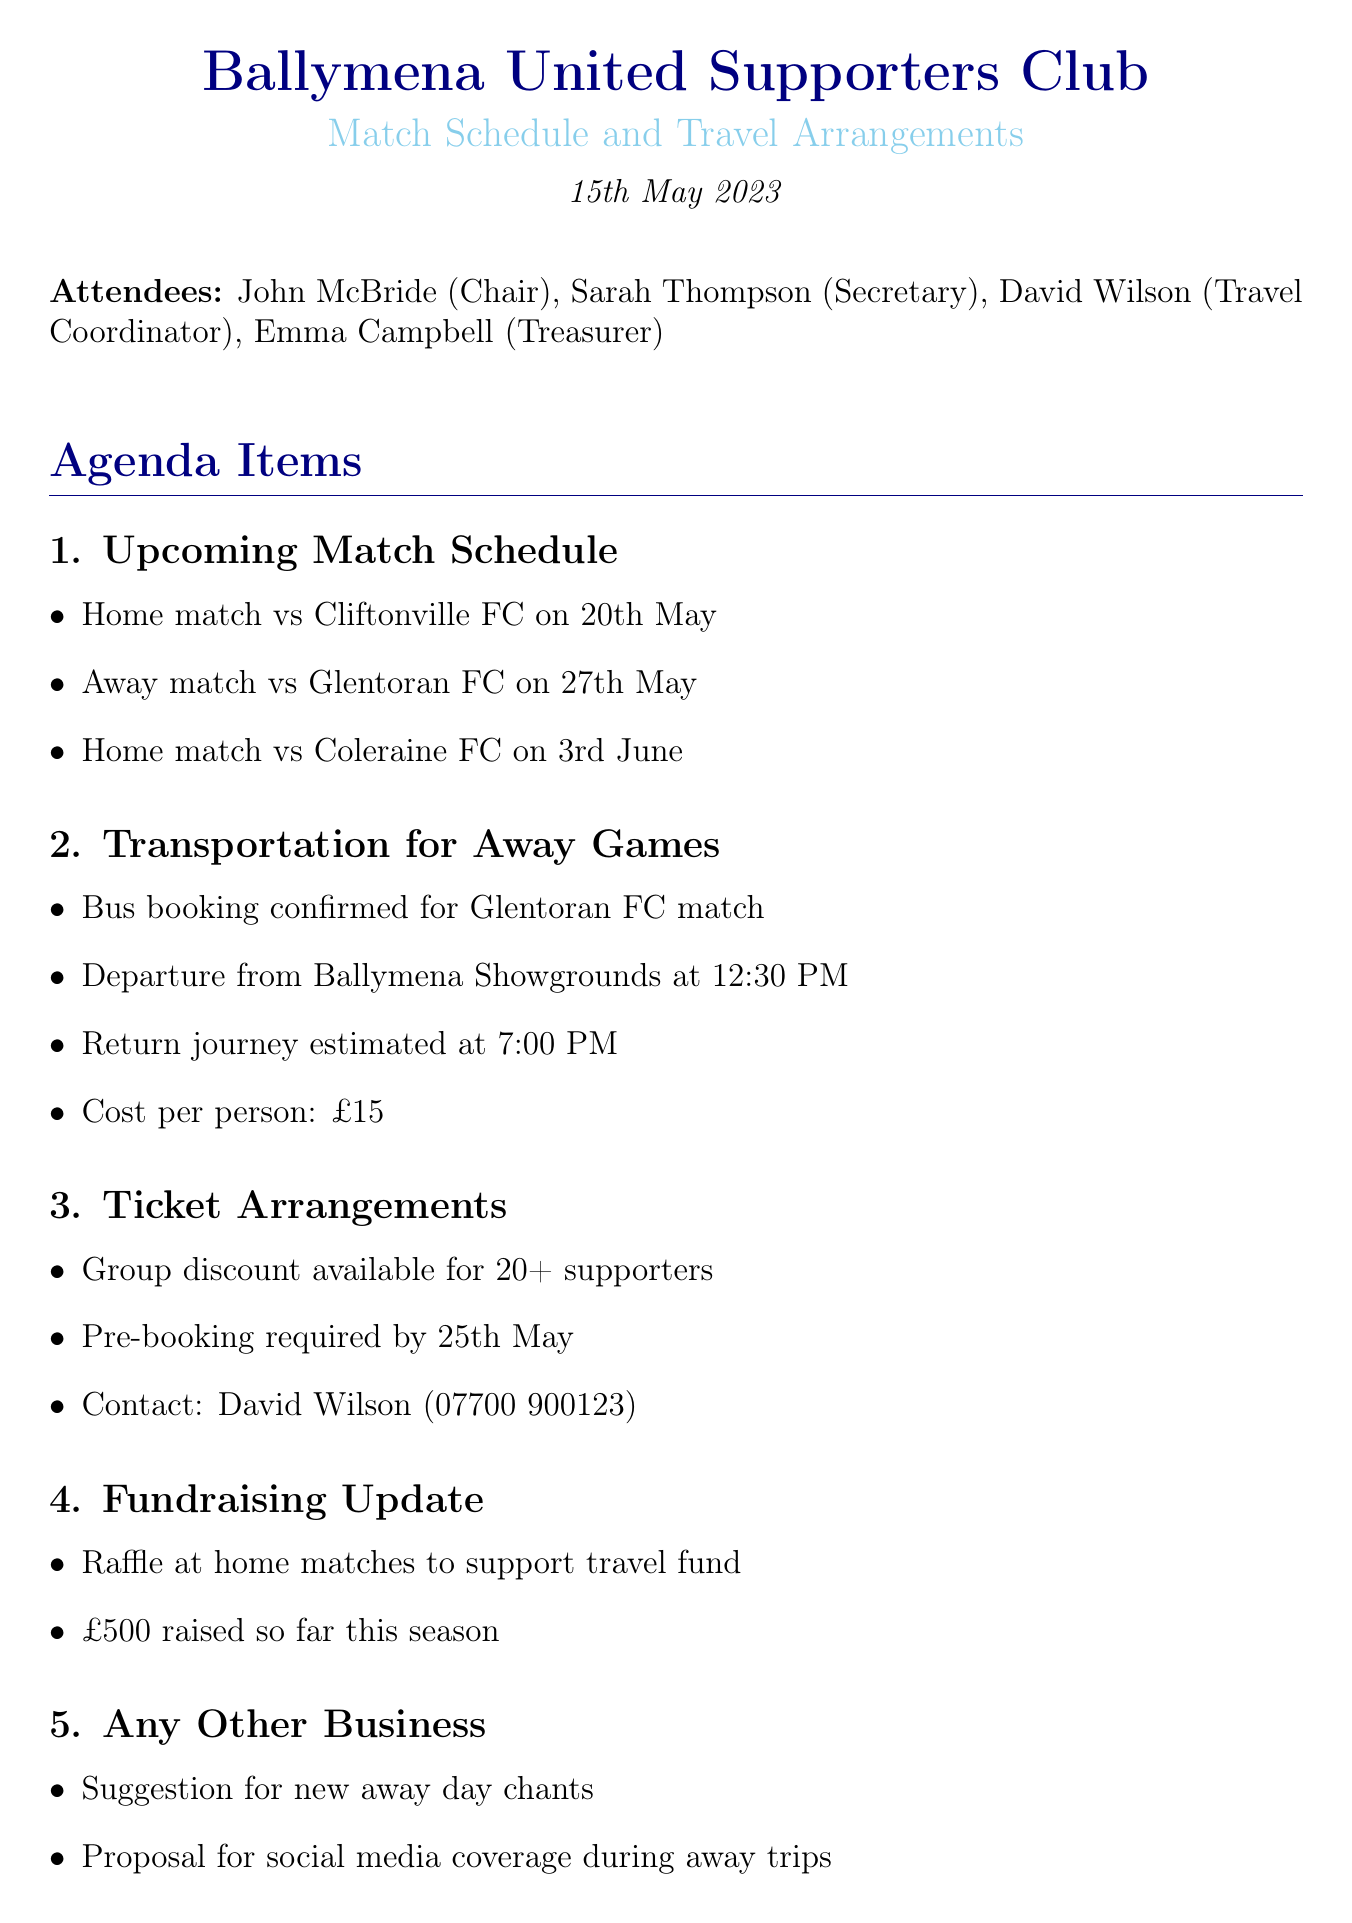what is the date of the meeting? The meeting was held on May 15, 2023, as stated in the document.
Answer: May 15, 2023 who is the Travel Coordinator? The document specifies that David Wilson holds the position of Travel Coordinator.
Answer: David Wilson when does the away match against Glentoran FC take place? The away match is scheduled for May 27, 2023, as mentioned in the match schedule section.
Answer: May 27 what is the cost per person for the away game transportation? The document states that the cost for transportation to the away game is £15 per person.
Answer: £15 what time will the bus depart for the Glentoran FC match? According to the transportation details, the bus will depart at 12:30 PM.
Answer: 12:30 PM how much has been raised for the travel fund so far this season? The fundraising update indicates that £500 has been raised for the travel fund.
Answer: £500 what action is Emma responsible for? The document lists that Emma is tasked with finalizing the bus payment by May 22.
Answer: finalize bus payment by 22nd May is a group discount available for tickets? The ticket arrangements mentioned in the document confirm that a group discount is available for groups of 20 or more supporters.
Answer: Yes by when must ticket pre-booking be done? The document specifies that ticket pre-booking is required by May 25.
Answer: May 25 